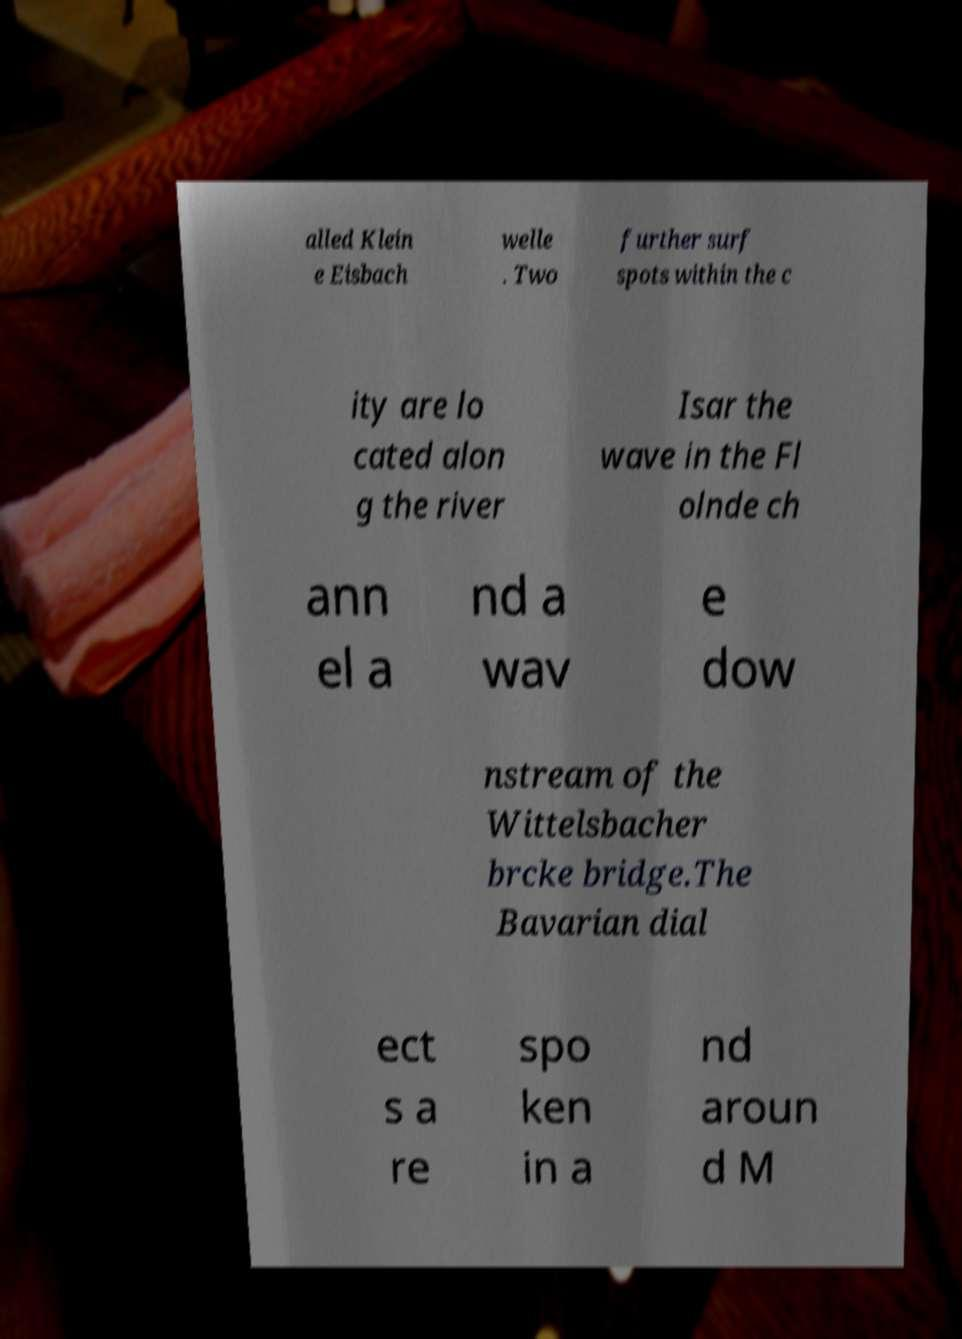Can you read and provide the text displayed in the image?This photo seems to have some interesting text. Can you extract and type it out for me? alled Klein e Eisbach welle . Two further surf spots within the c ity are lo cated alon g the river Isar the wave in the Fl olnde ch ann el a nd a wav e dow nstream of the Wittelsbacher brcke bridge.The Bavarian dial ect s a re spo ken in a nd aroun d M 